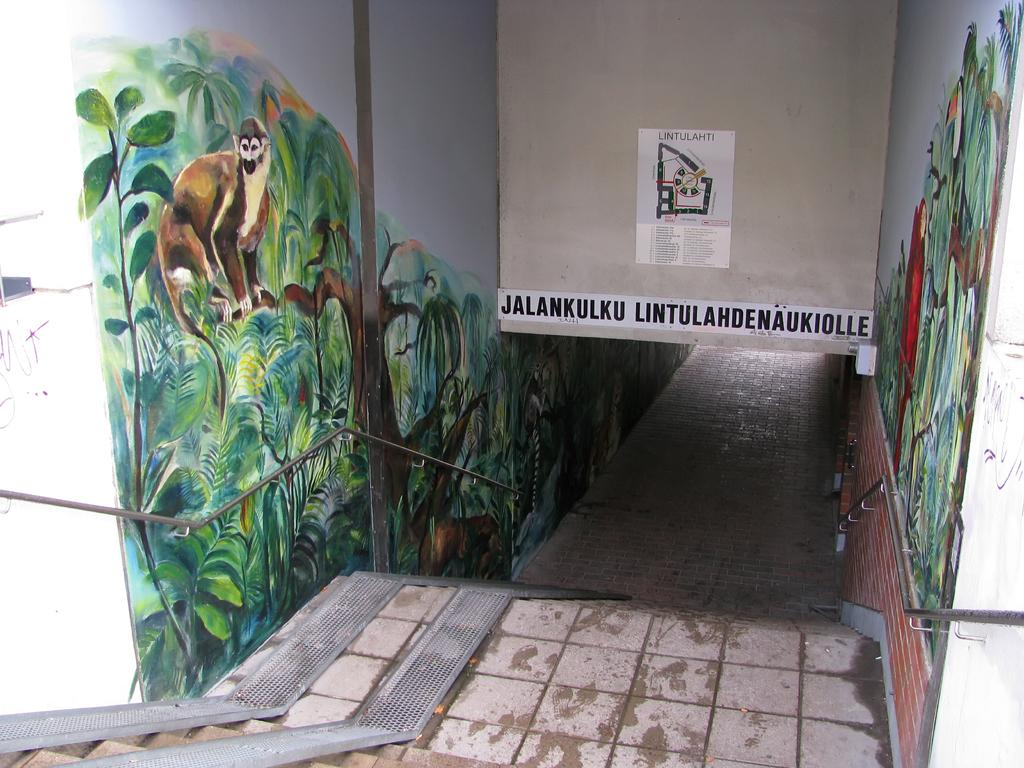What can be seen in the foreground of the image? There is a path in the foreground of the image. What is present on the walls alongside the path? There are paintings on the walls on either side of the path. What type of barrier is visible in the image? There is a railing visible in the image. What is located at the top of the image? There is a poster at the top of the image. What can be found on the walls in the image? There is text on the wall in the image. How many legs are visible in the image? There are no legs visible in the image; the focus is on the path, paintings, railing, poster, and text. Can you describe the group of people in the image? There is no group of people present in the image; it primarily features a path, paintings, railing, poster, and text. 